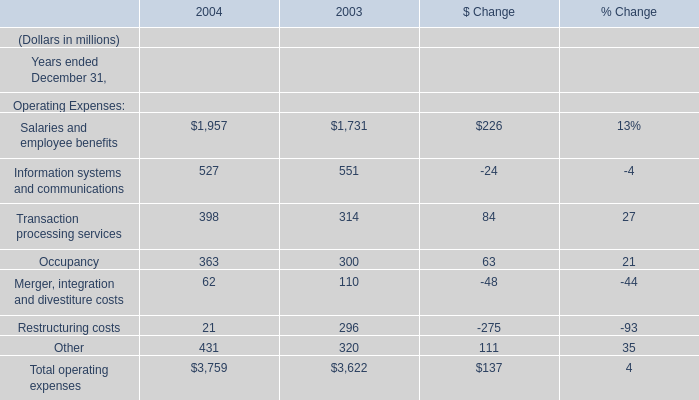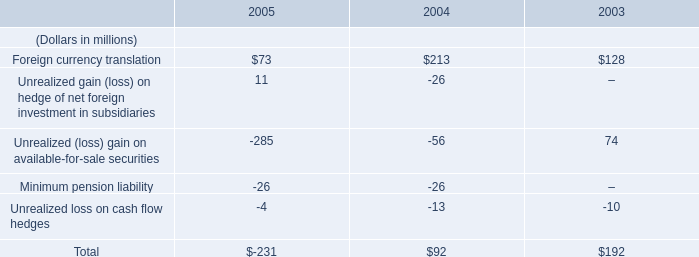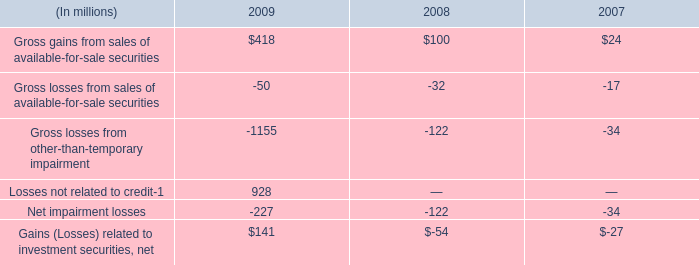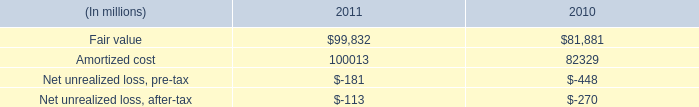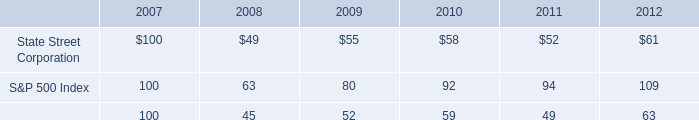What is the ratio of all Operating Expenses that are smaller than 100to the sum of Operating Expenses, in 2004? 
Computations: ((62 + 21) / 3759)
Answer: 0.02208. 